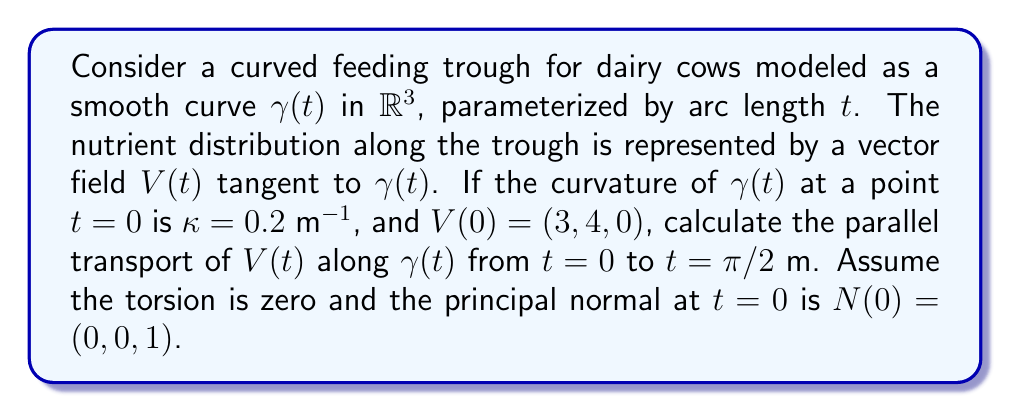Give your solution to this math problem. To solve this problem, we'll follow these steps:

1) Recall the equation for parallel transport along a curve:

   $$\frac{DV}{dt} = 0$$

   where $\frac{D}{dt}$ is the covariant derivative.

2) For a curve in $\mathbb{R}^3$, the parallel transport equation can be written as:

   $$\frac{dV}{dt} + \kappa(V \cdot N)T = 0$$

   where $\kappa$ is the curvature, $N$ is the principal normal, and $T$ is the unit tangent vector.

3) We're given $\kappa = 0.2$ m$^{-1}$ and $N(0) = (0, 0, 1)$. We need to find $T(0)$.

4) Since $V(0)$ is tangent to $\gamma(t)$ at $t=0$, we can normalize it to get $T(0)$:

   $$T(0) = \frac{V(0)}{||V(0)||} = \frac{(3, 4, 0)}{\sqrt{3^2 + 4^2}} = (\frac{3}{5}, \frac{4}{5}, 0)$$

5) Now we can set up the differential equation:

   $$\frac{dV}{dt} + 0.2(V \cdot (0, 0, 1))(\frac{3}{5}, \frac{4}{5}, 0) = 0$$

6) This simplifies to:

   $$\frac{dV}{dt} + 0.2V_z(\frac{3}{5}, \frac{4}{5}, 0) = 0$$

   where $V_z$ is the z-component of $V$.

7) We can solve this component-wise:

   $$\frac{dV_x}{dt} + 0.12V_z = 0$$
   $$\frac{dV_y}{dt} + 0.16V_z = 0$$
   $$\frac{dV_z}{dt} = 0$$

8) From the last equation, we see that $V_z$ is constant. Since $V_z(0) = 0$, $V_z(t) = 0$ for all $t$.

9) This means $V_x$ and $V_y$ are also constant. Therefore, $V(t) = V(0) = (3, 4, 0)$ for all $t$.

10) The parallel transport from $t=0$ to $t=\pi/2$ is thus $V(\pi/2) = (3, 4, 0)$.
Answer: $(3, 4, 0)$ 